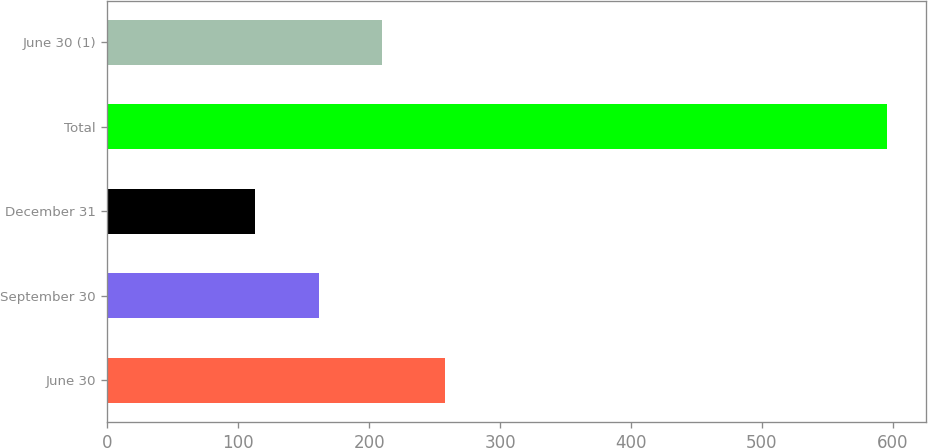<chart> <loc_0><loc_0><loc_500><loc_500><bar_chart><fcel>June 30<fcel>September 30<fcel>December 31<fcel>Total<fcel>June 30 (1)<nl><fcel>257.9<fcel>161.3<fcel>113<fcel>596<fcel>209.6<nl></chart> 